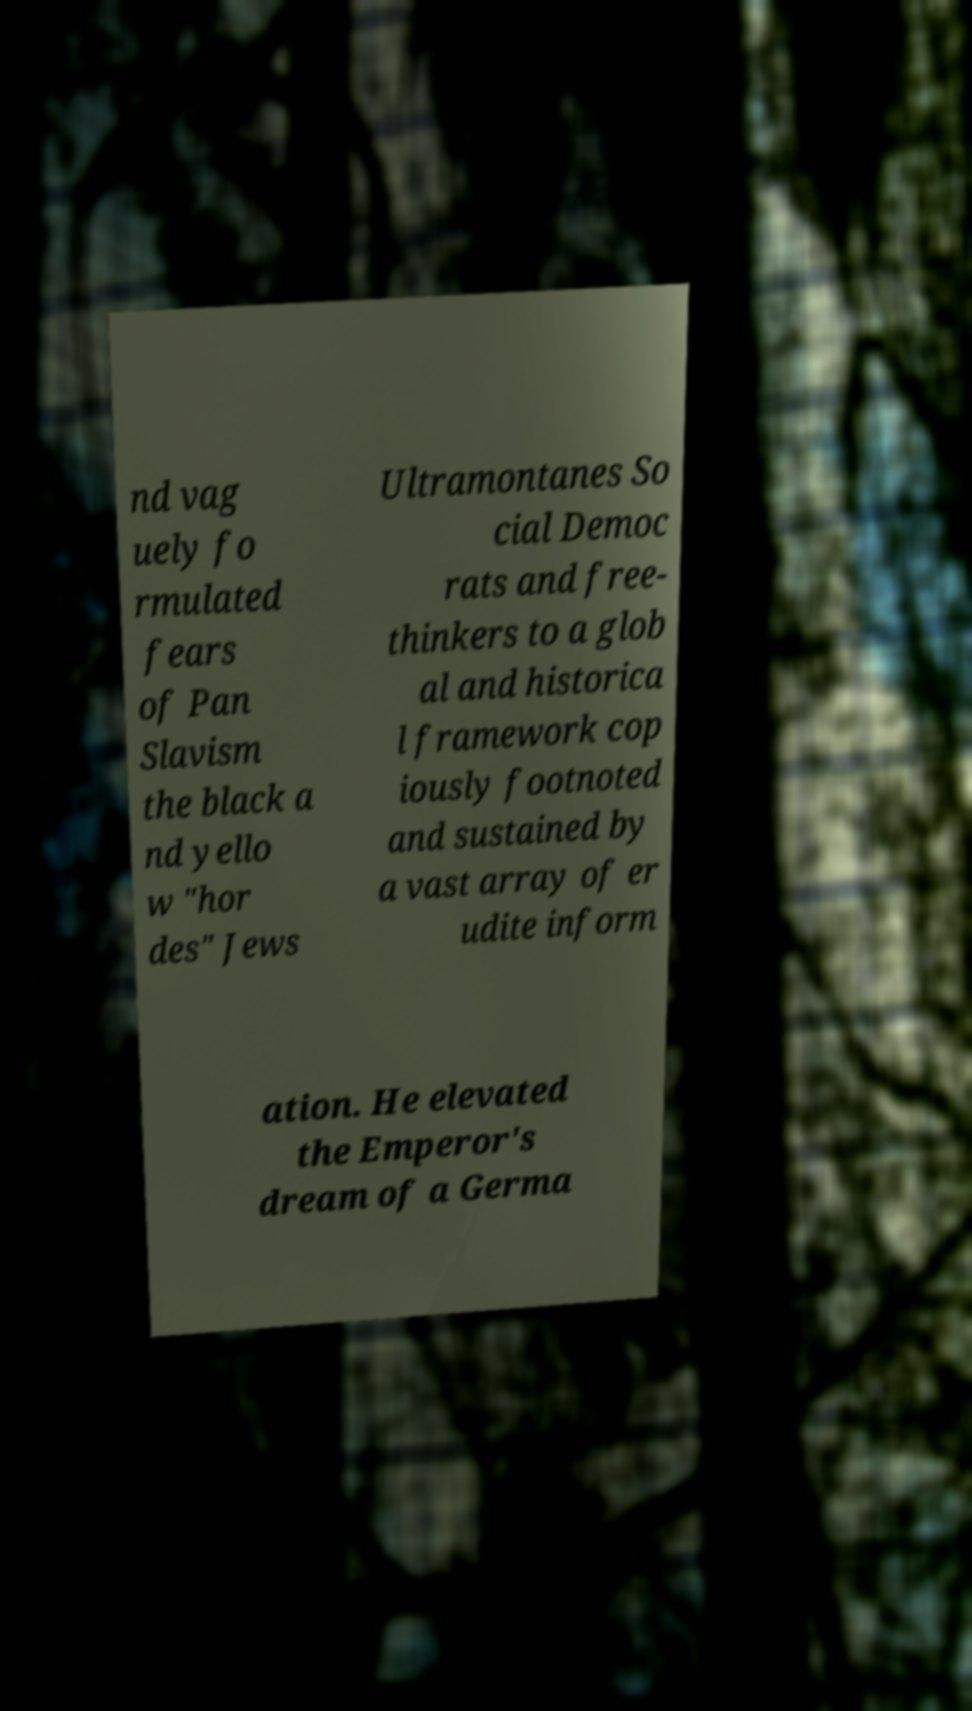For documentation purposes, I need the text within this image transcribed. Could you provide that? nd vag uely fo rmulated fears of Pan Slavism the black a nd yello w "hor des" Jews Ultramontanes So cial Democ rats and free- thinkers to a glob al and historica l framework cop iously footnoted and sustained by a vast array of er udite inform ation. He elevated the Emperor's dream of a Germa 